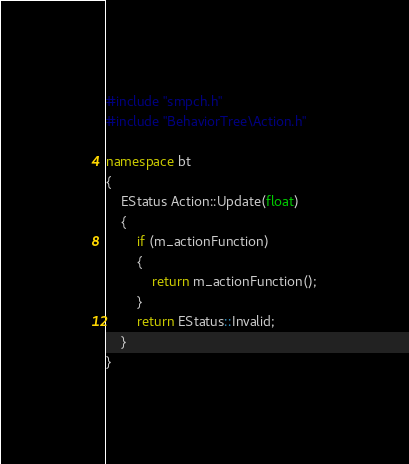<code> <loc_0><loc_0><loc_500><loc_500><_C++_>#include "smpch.h"
#include "BehaviorTree\Action.h"

namespace bt
{
	EStatus Action::Update(float)
	{
		if (m_actionFunction)
		{
			return m_actionFunction();
		}
		return EStatus::Invalid;
	}
}
</code> 